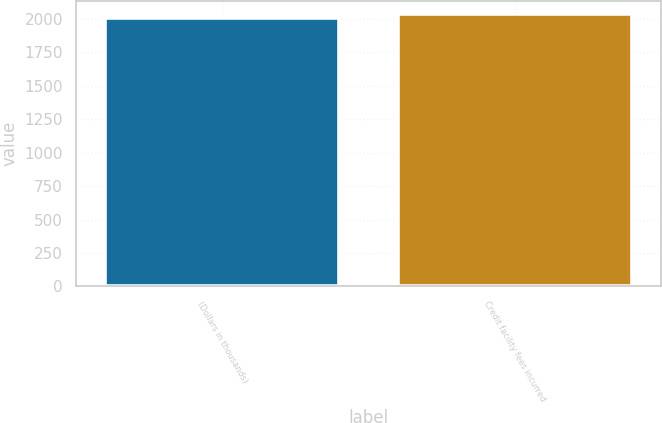<chart> <loc_0><loc_0><loc_500><loc_500><bar_chart><fcel>(Dollars in thousands)<fcel>Credit facility fees incurred<nl><fcel>2010<fcel>2034<nl></chart> 